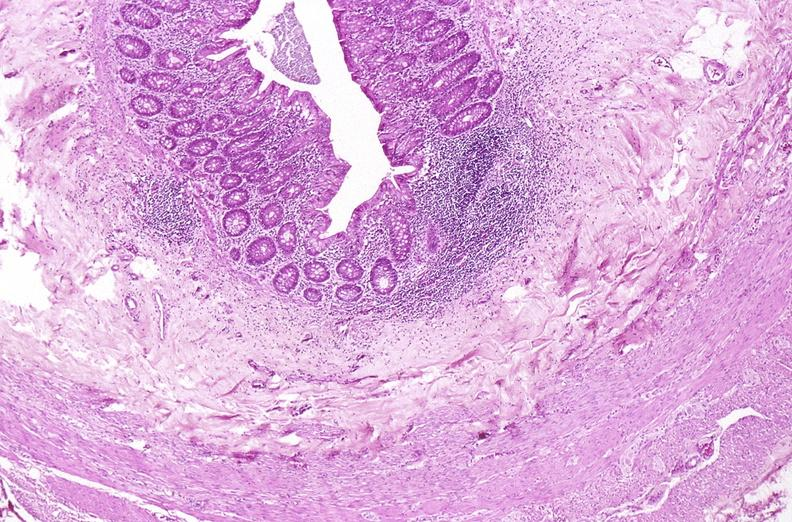does this image show appendix, normal histology?
Answer the question using a single word or phrase. Yes 